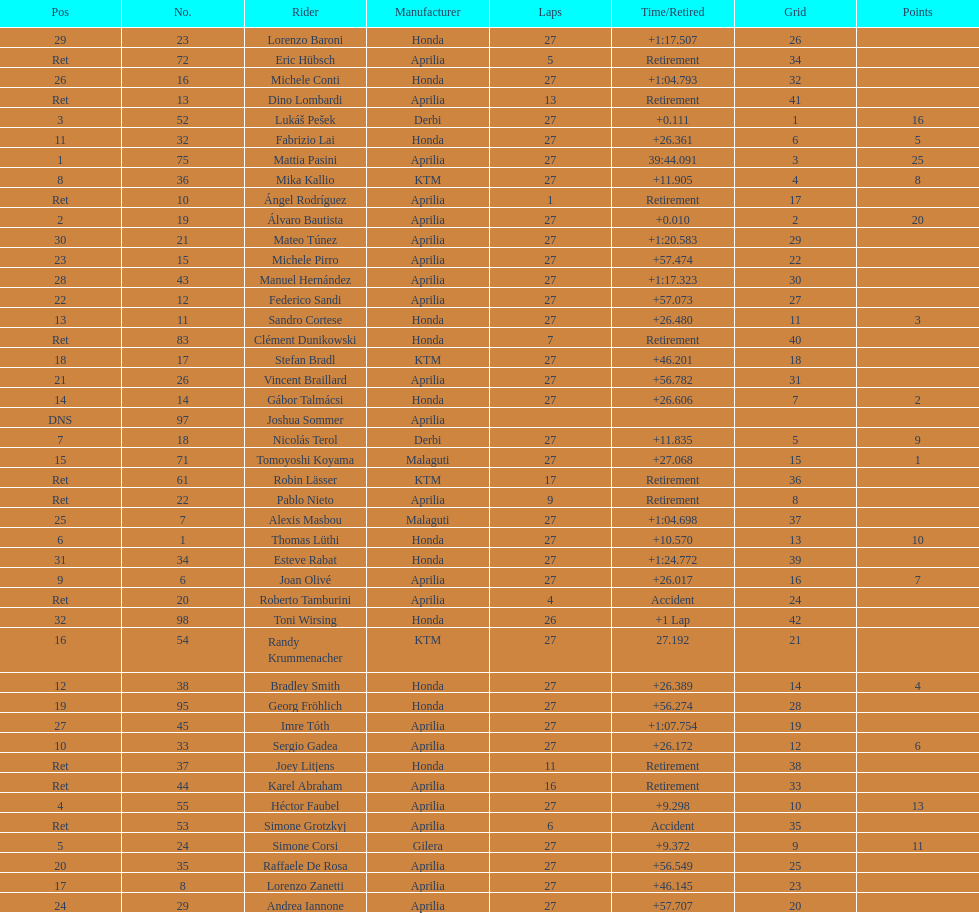Who holds the minimum points among those who have them? Tomoyoshi Koyama. 